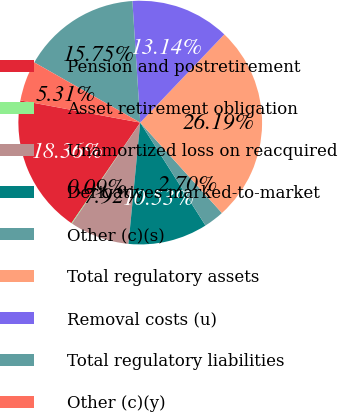Convert chart to OTSL. <chart><loc_0><loc_0><loc_500><loc_500><pie_chart><fcel>Pension and postretirement<fcel>Asset retirement obligation<fcel>Unamortized loss on reacquired<fcel>Derivatives marked-to-market<fcel>Other (c)(s)<fcel>Total regulatory assets<fcel>Removal costs (u)<fcel>Total regulatory liabilities<fcel>Other (c)(y)<nl><fcel>18.36%<fcel>0.09%<fcel>7.92%<fcel>10.53%<fcel>2.7%<fcel>26.19%<fcel>13.14%<fcel>15.75%<fcel>5.31%<nl></chart> 